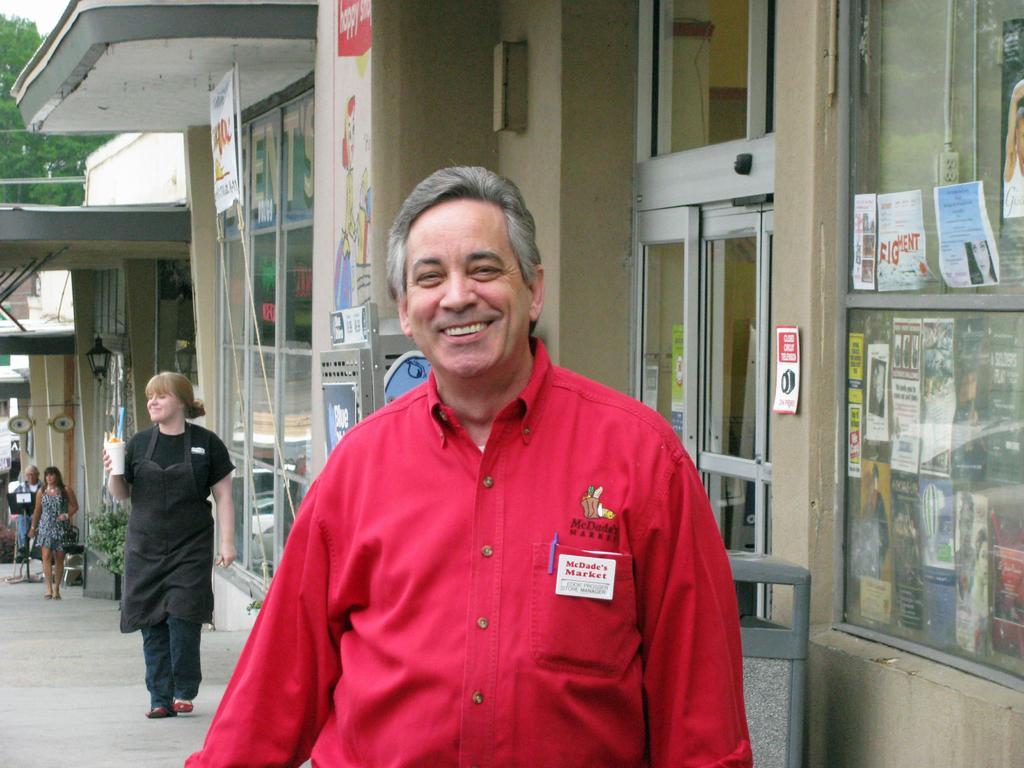Can you describe this image briefly? In this image I see a man over here who is wearing red shirt and I see that he is smiling and in the background I see few people on the path and I see the buildings and I see papers on which there are words written and I see the trees over here and I see a plant over here and I see a banner over here. 